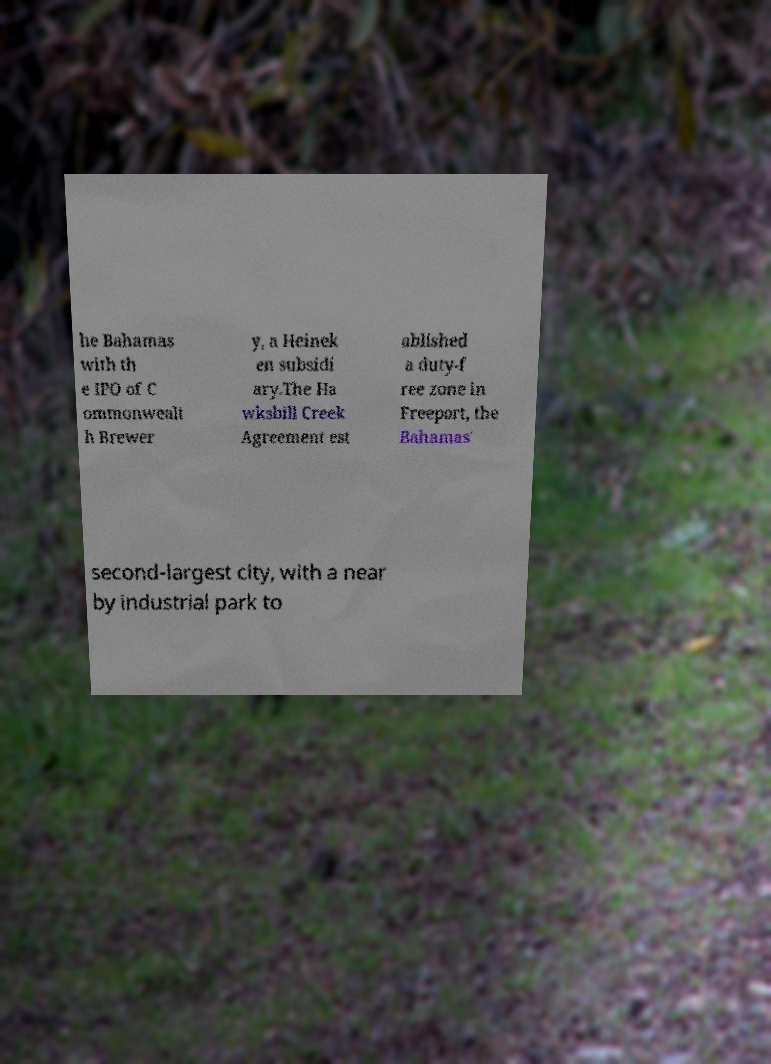I need the written content from this picture converted into text. Can you do that? he Bahamas with th e IPO of C ommonwealt h Brewer y, a Heinek en subsidi ary.The Ha wksbill Creek Agreement est ablished a duty-f ree zone in Freeport, the Bahamas' second-largest city, with a near by industrial park to 